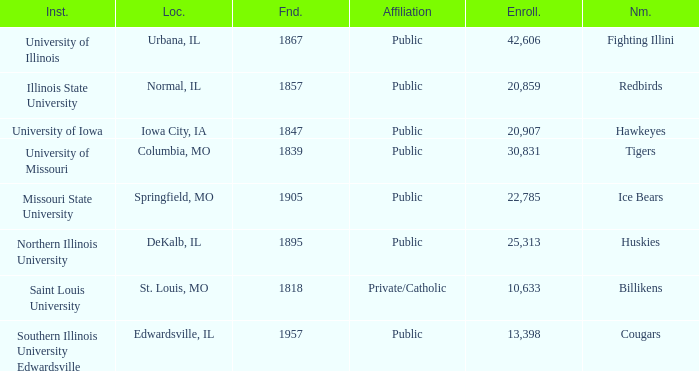Which institution is private/catholic? Saint Louis University. 